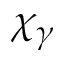Convert formula to latex. <formula><loc_0><loc_0><loc_500><loc_500>\chi _ { \gamma }</formula> 